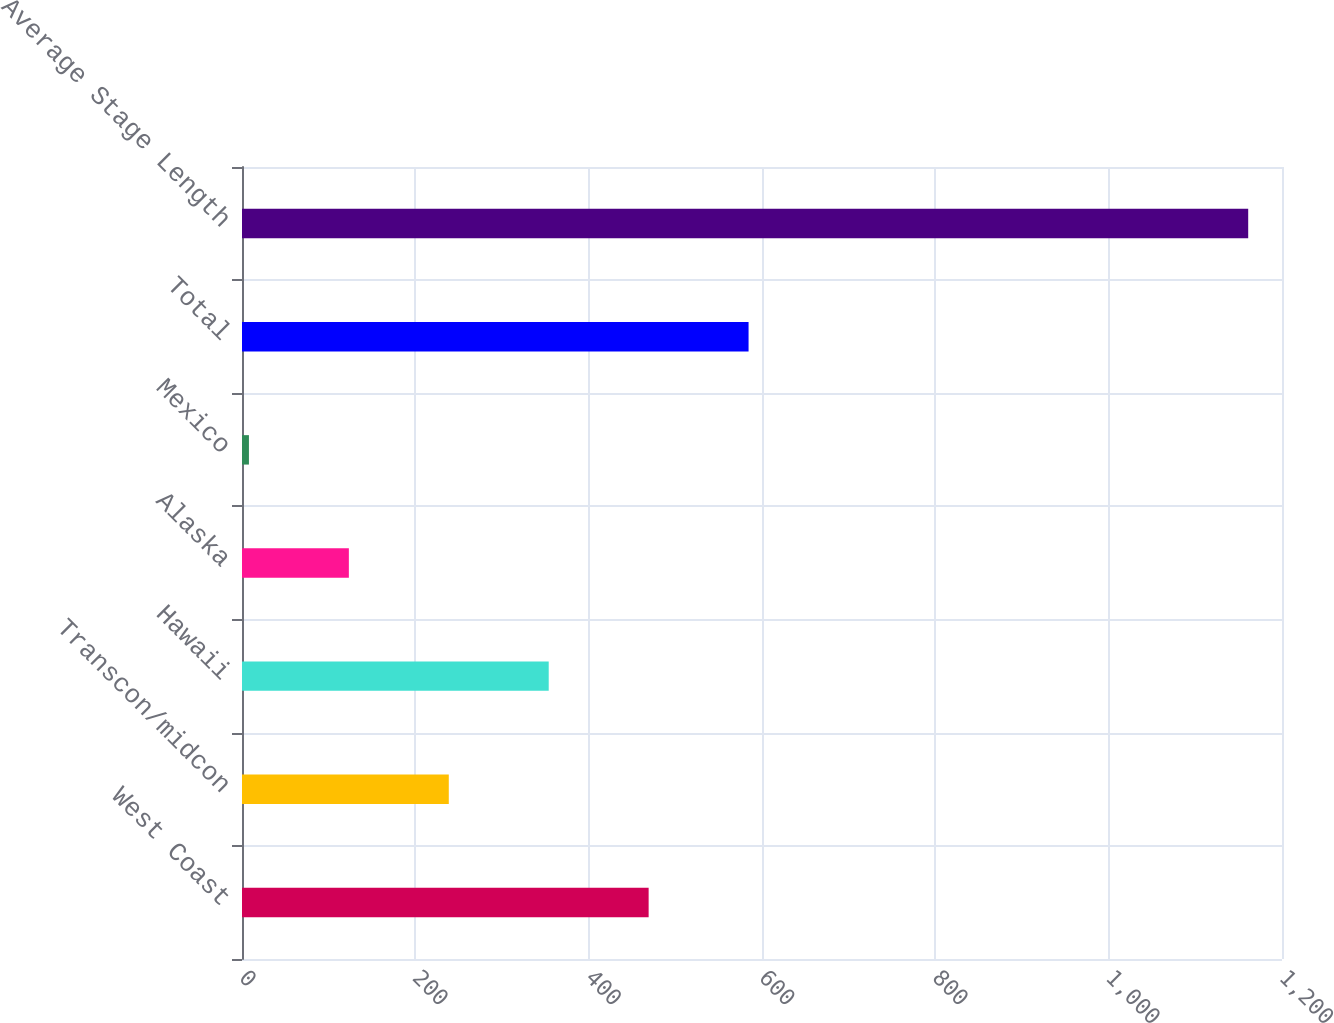Convert chart to OTSL. <chart><loc_0><loc_0><loc_500><loc_500><bar_chart><fcel>West Coast<fcel>Transcon/midcon<fcel>Hawaii<fcel>Alaska<fcel>Mexico<fcel>Total<fcel>Average Stage Length<nl><fcel>469.2<fcel>238.6<fcel>353.9<fcel>123.3<fcel>8<fcel>584.5<fcel>1161<nl></chart> 